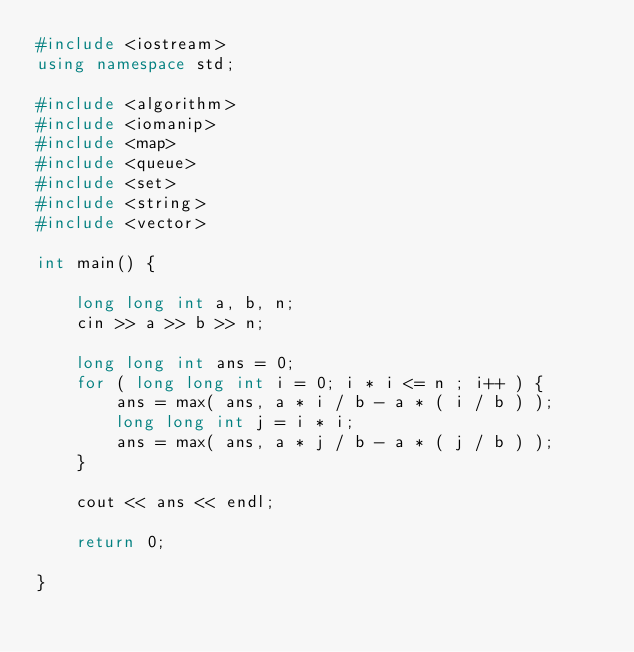Convert code to text. <code><loc_0><loc_0><loc_500><loc_500><_C++_>#include <iostream>
using namespace std;

#include <algorithm>
#include <iomanip>
#include <map>
#include <queue>
#include <set>
#include <string>
#include <vector>

int main() {

    long long int a, b, n;
    cin >> a >> b >> n;

    long long int ans = 0;
    for ( long long int i = 0; i * i <= n ; i++ ) {
        ans = max( ans, a * i / b - a * ( i / b ) );
        long long int j = i * i;
        ans = max( ans, a * j / b - a * ( j / b ) );
    }

    cout << ans << endl;

    return 0;

}
</code> 